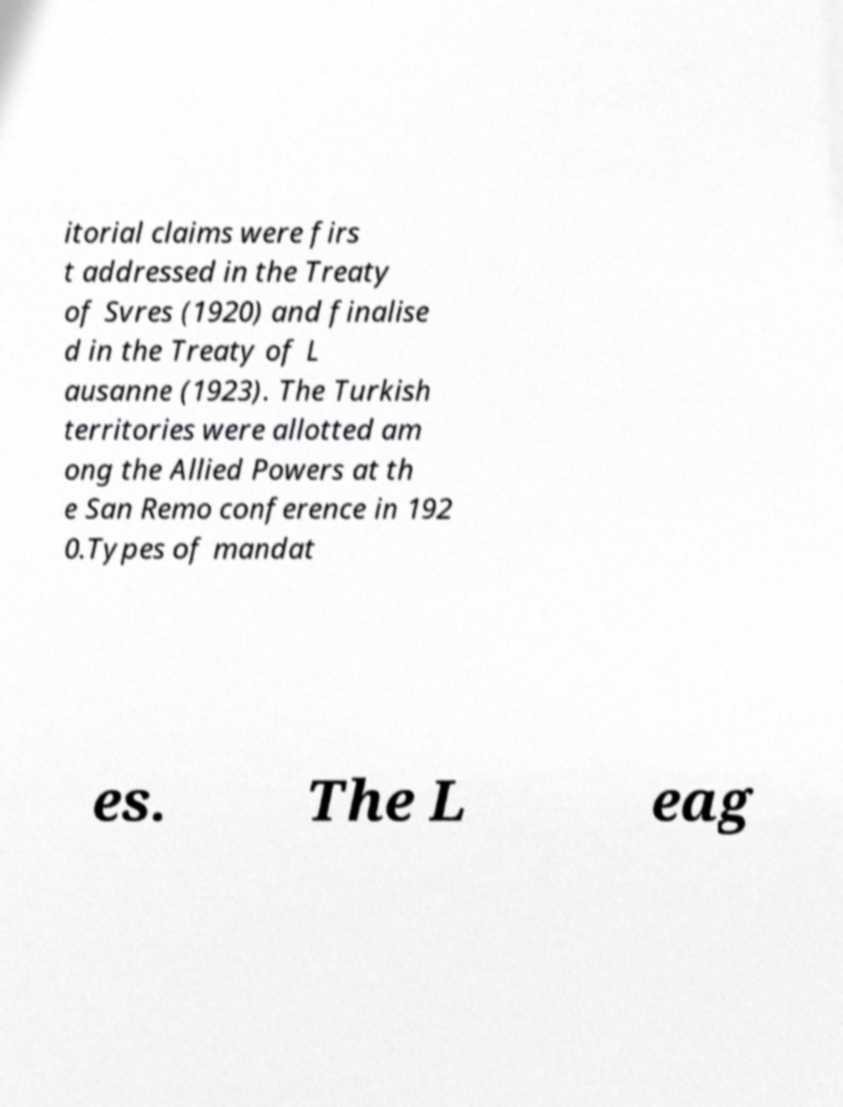Could you extract and type out the text from this image? itorial claims were firs t addressed in the Treaty of Svres (1920) and finalise d in the Treaty of L ausanne (1923). The Turkish territories were allotted am ong the Allied Powers at th e San Remo conference in 192 0.Types of mandat es. The L eag 